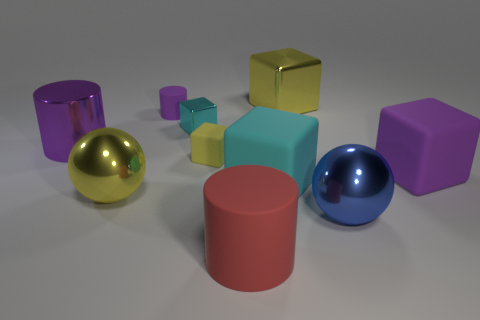Do the small cylinder and the metallic cylinder have the same color?
Offer a terse response. Yes. There is a block that is the same color as the tiny matte cylinder; what material is it?
Make the answer very short. Rubber. What shape is the tiny object that is the same color as the metal cylinder?
Make the answer very short. Cylinder. There is another block that is the same color as the large metal block; what size is it?
Provide a succinct answer. Small. There is a cylinder that is in front of the tiny cyan cube and to the left of the tiny metallic object; what color is it?
Make the answer very short. Purple. There is a matte object left of the cyan metallic thing that is behind the cyan rubber thing; is there a big cylinder in front of it?
Keep it short and to the point. Yes. There is a red object that is the same shape as the purple shiny thing; what is its size?
Your answer should be compact. Large. Are any red rubber blocks visible?
Provide a short and direct response. No. Is the color of the small metal object the same as the big cube that is to the left of the big yellow metal block?
Ensure brevity in your answer.  Yes. How big is the metallic thing on the right side of the cube behind the metal block in front of the big yellow shiny block?
Your response must be concise. Large. 